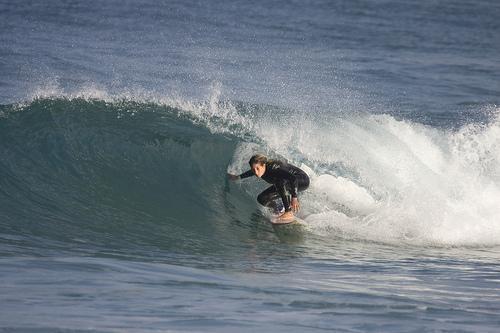How many people are in the photo?
Give a very brief answer. 1. 